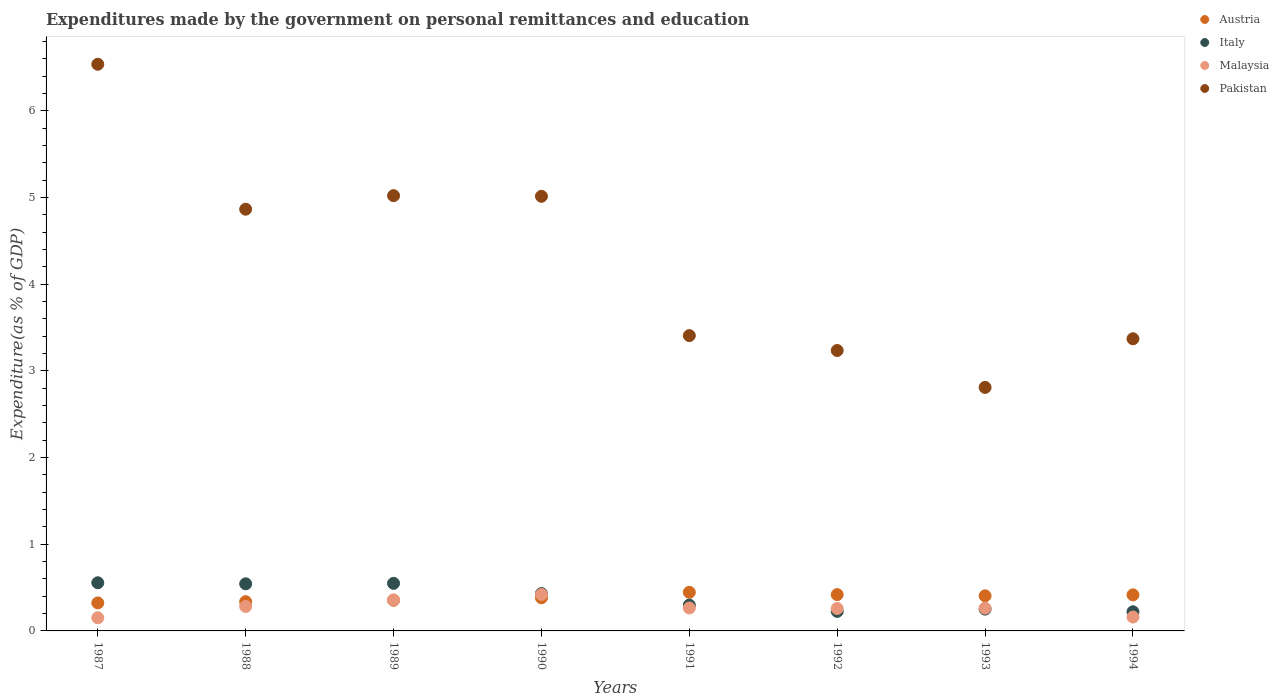How many different coloured dotlines are there?
Your answer should be very brief. 4. Is the number of dotlines equal to the number of legend labels?
Your response must be concise. Yes. What is the expenditures made by the government on personal remittances and education in Pakistan in 1994?
Your answer should be very brief. 3.37. Across all years, what is the maximum expenditures made by the government on personal remittances and education in Austria?
Give a very brief answer. 0.45. Across all years, what is the minimum expenditures made by the government on personal remittances and education in Pakistan?
Ensure brevity in your answer.  2.81. In which year was the expenditures made by the government on personal remittances and education in Pakistan maximum?
Provide a succinct answer. 1987. What is the total expenditures made by the government on personal remittances and education in Austria in the graph?
Your answer should be very brief. 3.08. What is the difference between the expenditures made by the government on personal remittances and education in Austria in 1987 and that in 1992?
Provide a short and direct response. -0.1. What is the difference between the expenditures made by the government on personal remittances and education in Italy in 1988 and the expenditures made by the government on personal remittances and education in Malaysia in 1994?
Ensure brevity in your answer.  0.38. What is the average expenditures made by the government on personal remittances and education in Pakistan per year?
Make the answer very short. 4.28. In the year 1990, what is the difference between the expenditures made by the government on personal remittances and education in Italy and expenditures made by the government on personal remittances and education in Pakistan?
Provide a succinct answer. -4.58. What is the ratio of the expenditures made by the government on personal remittances and education in Italy in 1988 to that in 1994?
Your response must be concise. 2.46. What is the difference between the highest and the second highest expenditures made by the government on personal remittances and education in Malaysia?
Ensure brevity in your answer.  0.06. What is the difference between the highest and the lowest expenditures made by the government on personal remittances and education in Pakistan?
Ensure brevity in your answer.  3.73. Is it the case that in every year, the sum of the expenditures made by the government on personal remittances and education in Italy and expenditures made by the government on personal remittances and education in Pakistan  is greater than the expenditures made by the government on personal remittances and education in Austria?
Offer a very short reply. Yes. Is the expenditures made by the government on personal remittances and education in Malaysia strictly greater than the expenditures made by the government on personal remittances and education in Italy over the years?
Keep it short and to the point. No. How many dotlines are there?
Offer a very short reply. 4. What is the difference between two consecutive major ticks on the Y-axis?
Make the answer very short. 1. Does the graph contain any zero values?
Your answer should be compact. No. How are the legend labels stacked?
Offer a terse response. Vertical. What is the title of the graph?
Your answer should be compact. Expenditures made by the government on personal remittances and education. Does "Iceland" appear as one of the legend labels in the graph?
Your answer should be compact. No. What is the label or title of the Y-axis?
Your answer should be very brief. Expenditure(as % of GDP). What is the Expenditure(as % of GDP) of Austria in 1987?
Keep it short and to the point. 0.32. What is the Expenditure(as % of GDP) in Italy in 1987?
Keep it short and to the point. 0.56. What is the Expenditure(as % of GDP) in Malaysia in 1987?
Make the answer very short. 0.15. What is the Expenditure(as % of GDP) of Pakistan in 1987?
Make the answer very short. 6.54. What is the Expenditure(as % of GDP) of Austria in 1988?
Offer a very short reply. 0.34. What is the Expenditure(as % of GDP) of Italy in 1988?
Ensure brevity in your answer.  0.54. What is the Expenditure(as % of GDP) in Malaysia in 1988?
Give a very brief answer. 0.28. What is the Expenditure(as % of GDP) in Pakistan in 1988?
Keep it short and to the point. 4.87. What is the Expenditure(as % of GDP) of Austria in 1989?
Provide a short and direct response. 0.35. What is the Expenditure(as % of GDP) of Italy in 1989?
Provide a succinct answer. 0.55. What is the Expenditure(as % of GDP) of Malaysia in 1989?
Your answer should be very brief. 0.36. What is the Expenditure(as % of GDP) of Pakistan in 1989?
Offer a very short reply. 5.02. What is the Expenditure(as % of GDP) in Austria in 1990?
Your answer should be compact. 0.38. What is the Expenditure(as % of GDP) of Italy in 1990?
Your answer should be compact. 0.43. What is the Expenditure(as % of GDP) in Malaysia in 1990?
Make the answer very short. 0.42. What is the Expenditure(as % of GDP) of Pakistan in 1990?
Your answer should be compact. 5.01. What is the Expenditure(as % of GDP) of Austria in 1991?
Your answer should be compact. 0.45. What is the Expenditure(as % of GDP) of Italy in 1991?
Your answer should be very brief. 0.3. What is the Expenditure(as % of GDP) in Malaysia in 1991?
Provide a succinct answer. 0.26. What is the Expenditure(as % of GDP) in Pakistan in 1991?
Your answer should be compact. 3.41. What is the Expenditure(as % of GDP) in Austria in 1992?
Make the answer very short. 0.42. What is the Expenditure(as % of GDP) of Italy in 1992?
Make the answer very short. 0.23. What is the Expenditure(as % of GDP) in Malaysia in 1992?
Your answer should be very brief. 0.26. What is the Expenditure(as % of GDP) of Pakistan in 1992?
Give a very brief answer. 3.24. What is the Expenditure(as % of GDP) in Austria in 1993?
Offer a terse response. 0.4. What is the Expenditure(as % of GDP) in Italy in 1993?
Give a very brief answer. 0.25. What is the Expenditure(as % of GDP) of Malaysia in 1993?
Your answer should be very brief. 0.26. What is the Expenditure(as % of GDP) in Pakistan in 1993?
Provide a short and direct response. 2.81. What is the Expenditure(as % of GDP) of Austria in 1994?
Your response must be concise. 0.42. What is the Expenditure(as % of GDP) of Italy in 1994?
Provide a short and direct response. 0.22. What is the Expenditure(as % of GDP) of Malaysia in 1994?
Provide a succinct answer. 0.16. What is the Expenditure(as % of GDP) in Pakistan in 1994?
Your answer should be compact. 3.37. Across all years, what is the maximum Expenditure(as % of GDP) of Austria?
Your answer should be very brief. 0.45. Across all years, what is the maximum Expenditure(as % of GDP) of Italy?
Ensure brevity in your answer.  0.56. Across all years, what is the maximum Expenditure(as % of GDP) in Malaysia?
Give a very brief answer. 0.42. Across all years, what is the maximum Expenditure(as % of GDP) in Pakistan?
Keep it short and to the point. 6.54. Across all years, what is the minimum Expenditure(as % of GDP) of Austria?
Make the answer very short. 0.32. Across all years, what is the minimum Expenditure(as % of GDP) of Italy?
Ensure brevity in your answer.  0.22. Across all years, what is the minimum Expenditure(as % of GDP) in Malaysia?
Ensure brevity in your answer.  0.15. Across all years, what is the minimum Expenditure(as % of GDP) in Pakistan?
Make the answer very short. 2.81. What is the total Expenditure(as % of GDP) of Austria in the graph?
Your response must be concise. 3.08. What is the total Expenditure(as % of GDP) in Italy in the graph?
Give a very brief answer. 3.07. What is the total Expenditure(as % of GDP) of Malaysia in the graph?
Your answer should be compact. 2.16. What is the total Expenditure(as % of GDP) in Pakistan in the graph?
Keep it short and to the point. 34.26. What is the difference between the Expenditure(as % of GDP) in Austria in 1987 and that in 1988?
Offer a terse response. -0.01. What is the difference between the Expenditure(as % of GDP) in Italy in 1987 and that in 1988?
Make the answer very short. 0.01. What is the difference between the Expenditure(as % of GDP) of Malaysia in 1987 and that in 1988?
Your response must be concise. -0.13. What is the difference between the Expenditure(as % of GDP) of Pakistan in 1987 and that in 1988?
Provide a succinct answer. 1.67. What is the difference between the Expenditure(as % of GDP) of Austria in 1987 and that in 1989?
Provide a short and direct response. -0.03. What is the difference between the Expenditure(as % of GDP) of Italy in 1987 and that in 1989?
Make the answer very short. 0.01. What is the difference between the Expenditure(as % of GDP) in Malaysia in 1987 and that in 1989?
Ensure brevity in your answer.  -0.21. What is the difference between the Expenditure(as % of GDP) of Pakistan in 1987 and that in 1989?
Provide a short and direct response. 1.52. What is the difference between the Expenditure(as % of GDP) in Austria in 1987 and that in 1990?
Provide a short and direct response. -0.06. What is the difference between the Expenditure(as % of GDP) of Italy in 1987 and that in 1990?
Give a very brief answer. 0.12. What is the difference between the Expenditure(as % of GDP) of Malaysia in 1987 and that in 1990?
Your answer should be compact. -0.27. What is the difference between the Expenditure(as % of GDP) in Pakistan in 1987 and that in 1990?
Your answer should be compact. 1.52. What is the difference between the Expenditure(as % of GDP) in Austria in 1987 and that in 1991?
Ensure brevity in your answer.  -0.12. What is the difference between the Expenditure(as % of GDP) of Italy in 1987 and that in 1991?
Your answer should be very brief. 0.26. What is the difference between the Expenditure(as % of GDP) of Malaysia in 1987 and that in 1991?
Keep it short and to the point. -0.11. What is the difference between the Expenditure(as % of GDP) in Pakistan in 1987 and that in 1991?
Provide a succinct answer. 3.13. What is the difference between the Expenditure(as % of GDP) of Austria in 1987 and that in 1992?
Ensure brevity in your answer.  -0.1. What is the difference between the Expenditure(as % of GDP) in Italy in 1987 and that in 1992?
Keep it short and to the point. 0.33. What is the difference between the Expenditure(as % of GDP) of Malaysia in 1987 and that in 1992?
Offer a very short reply. -0.11. What is the difference between the Expenditure(as % of GDP) in Pakistan in 1987 and that in 1992?
Your response must be concise. 3.3. What is the difference between the Expenditure(as % of GDP) of Austria in 1987 and that in 1993?
Make the answer very short. -0.08. What is the difference between the Expenditure(as % of GDP) in Italy in 1987 and that in 1993?
Offer a very short reply. 0.3. What is the difference between the Expenditure(as % of GDP) in Malaysia in 1987 and that in 1993?
Give a very brief answer. -0.11. What is the difference between the Expenditure(as % of GDP) of Pakistan in 1987 and that in 1993?
Your response must be concise. 3.73. What is the difference between the Expenditure(as % of GDP) in Austria in 1987 and that in 1994?
Offer a terse response. -0.09. What is the difference between the Expenditure(as % of GDP) in Italy in 1987 and that in 1994?
Your response must be concise. 0.33. What is the difference between the Expenditure(as % of GDP) in Malaysia in 1987 and that in 1994?
Ensure brevity in your answer.  -0.01. What is the difference between the Expenditure(as % of GDP) in Pakistan in 1987 and that in 1994?
Give a very brief answer. 3.17. What is the difference between the Expenditure(as % of GDP) of Austria in 1988 and that in 1989?
Provide a short and direct response. -0.02. What is the difference between the Expenditure(as % of GDP) in Italy in 1988 and that in 1989?
Your response must be concise. -0.01. What is the difference between the Expenditure(as % of GDP) in Malaysia in 1988 and that in 1989?
Ensure brevity in your answer.  -0.07. What is the difference between the Expenditure(as % of GDP) in Pakistan in 1988 and that in 1989?
Your answer should be compact. -0.16. What is the difference between the Expenditure(as % of GDP) in Austria in 1988 and that in 1990?
Make the answer very short. -0.04. What is the difference between the Expenditure(as % of GDP) in Italy in 1988 and that in 1990?
Your answer should be compact. 0.11. What is the difference between the Expenditure(as % of GDP) of Malaysia in 1988 and that in 1990?
Your answer should be very brief. -0.14. What is the difference between the Expenditure(as % of GDP) of Pakistan in 1988 and that in 1990?
Give a very brief answer. -0.15. What is the difference between the Expenditure(as % of GDP) in Austria in 1988 and that in 1991?
Ensure brevity in your answer.  -0.11. What is the difference between the Expenditure(as % of GDP) in Italy in 1988 and that in 1991?
Make the answer very short. 0.25. What is the difference between the Expenditure(as % of GDP) in Malaysia in 1988 and that in 1991?
Offer a very short reply. 0.02. What is the difference between the Expenditure(as % of GDP) in Pakistan in 1988 and that in 1991?
Offer a very short reply. 1.46. What is the difference between the Expenditure(as % of GDP) of Austria in 1988 and that in 1992?
Offer a terse response. -0.08. What is the difference between the Expenditure(as % of GDP) in Italy in 1988 and that in 1992?
Ensure brevity in your answer.  0.32. What is the difference between the Expenditure(as % of GDP) in Malaysia in 1988 and that in 1992?
Give a very brief answer. 0.02. What is the difference between the Expenditure(as % of GDP) of Pakistan in 1988 and that in 1992?
Make the answer very short. 1.63. What is the difference between the Expenditure(as % of GDP) in Austria in 1988 and that in 1993?
Provide a succinct answer. -0.07. What is the difference between the Expenditure(as % of GDP) of Italy in 1988 and that in 1993?
Provide a short and direct response. 0.29. What is the difference between the Expenditure(as % of GDP) in Malaysia in 1988 and that in 1993?
Keep it short and to the point. 0.02. What is the difference between the Expenditure(as % of GDP) of Pakistan in 1988 and that in 1993?
Your answer should be compact. 2.06. What is the difference between the Expenditure(as % of GDP) of Austria in 1988 and that in 1994?
Ensure brevity in your answer.  -0.08. What is the difference between the Expenditure(as % of GDP) of Italy in 1988 and that in 1994?
Provide a succinct answer. 0.32. What is the difference between the Expenditure(as % of GDP) of Malaysia in 1988 and that in 1994?
Provide a short and direct response. 0.12. What is the difference between the Expenditure(as % of GDP) in Pakistan in 1988 and that in 1994?
Make the answer very short. 1.49. What is the difference between the Expenditure(as % of GDP) in Austria in 1989 and that in 1990?
Make the answer very short. -0.03. What is the difference between the Expenditure(as % of GDP) in Italy in 1989 and that in 1990?
Keep it short and to the point. 0.12. What is the difference between the Expenditure(as % of GDP) in Malaysia in 1989 and that in 1990?
Provide a short and direct response. -0.06. What is the difference between the Expenditure(as % of GDP) in Pakistan in 1989 and that in 1990?
Provide a succinct answer. 0.01. What is the difference between the Expenditure(as % of GDP) of Austria in 1989 and that in 1991?
Offer a terse response. -0.09. What is the difference between the Expenditure(as % of GDP) of Italy in 1989 and that in 1991?
Provide a short and direct response. 0.25. What is the difference between the Expenditure(as % of GDP) of Malaysia in 1989 and that in 1991?
Keep it short and to the point. 0.09. What is the difference between the Expenditure(as % of GDP) in Pakistan in 1989 and that in 1991?
Ensure brevity in your answer.  1.61. What is the difference between the Expenditure(as % of GDP) in Austria in 1989 and that in 1992?
Your response must be concise. -0.07. What is the difference between the Expenditure(as % of GDP) of Italy in 1989 and that in 1992?
Ensure brevity in your answer.  0.32. What is the difference between the Expenditure(as % of GDP) in Malaysia in 1989 and that in 1992?
Keep it short and to the point. 0.1. What is the difference between the Expenditure(as % of GDP) in Pakistan in 1989 and that in 1992?
Your answer should be compact. 1.79. What is the difference between the Expenditure(as % of GDP) in Austria in 1989 and that in 1993?
Your answer should be compact. -0.05. What is the difference between the Expenditure(as % of GDP) in Italy in 1989 and that in 1993?
Ensure brevity in your answer.  0.3. What is the difference between the Expenditure(as % of GDP) of Malaysia in 1989 and that in 1993?
Ensure brevity in your answer.  0.09. What is the difference between the Expenditure(as % of GDP) in Pakistan in 1989 and that in 1993?
Your answer should be very brief. 2.21. What is the difference between the Expenditure(as % of GDP) in Austria in 1989 and that in 1994?
Provide a succinct answer. -0.06. What is the difference between the Expenditure(as % of GDP) of Italy in 1989 and that in 1994?
Your answer should be very brief. 0.33. What is the difference between the Expenditure(as % of GDP) of Malaysia in 1989 and that in 1994?
Your answer should be compact. 0.2. What is the difference between the Expenditure(as % of GDP) of Pakistan in 1989 and that in 1994?
Provide a succinct answer. 1.65. What is the difference between the Expenditure(as % of GDP) in Austria in 1990 and that in 1991?
Provide a short and direct response. -0.06. What is the difference between the Expenditure(as % of GDP) in Italy in 1990 and that in 1991?
Offer a very short reply. 0.13. What is the difference between the Expenditure(as % of GDP) of Malaysia in 1990 and that in 1991?
Offer a very short reply. 0.16. What is the difference between the Expenditure(as % of GDP) in Pakistan in 1990 and that in 1991?
Provide a short and direct response. 1.61. What is the difference between the Expenditure(as % of GDP) in Austria in 1990 and that in 1992?
Make the answer very short. -0.04. What is the difference between the Expenditure(as % of GDP) of Italy in 1990 and that in 1992?
Your answer should be compact. 0.21. What is the difference between the Expenditure(as % of GDP) of Malaysia in 1990 and that in 1992?
Provide a short and direct response. 0.16. What is the difference between the Expenditure(as % of GDP) in Pakistan in 1990 and that in 1992?
Your answer should be compact. 1.78. What is the difference between the Expenditure(as % of GDP) in Austria in 1990 and that in 1993?
Provide a short and direct response. -0.02. What is the difference between the Expenditure(as % of GDP) of Italy in 1990 and that in 1993?
Your answer should be compact. 0.18. What is the difference between the Expenditure(as % of GDP) of Malaysia in 1990 and that in 1993?
Ensure brevity in your answer.  0.16. What is the difference between the Expenditure(as % of GDP) in Pakistan in 1990 and that in 1993?
Make the answer very short. 2.2. What is the difference between the Expenditure(as % of GDP) in Austria in 1990 and that in 1994?
Give a very brief answer. -0.03. What is the difference between the Expenditure(as % of GDP) in Italy in 1990 and that in 1994?
Ensure brevity in your answer.  0.21. What is the difference between the Expenditure(as % of GDP) of Malaysia in 1990 and that in 1994?
Your response must be concise. 0.26. What is the difference between the Expenditure(as % of GDP) in Pakistan in 1990 and that in 1994?
Provide a succinct answer. 1.64. What is the difference between the Expenditure(as % of GDP) of Austria in 1991 and that in 1992?
Offer a terse response. 0.03. What is the difference between the Expenditure(as % of GDP) of Italy in 1991 and that in 1992?
Offer a terse response. 0.07. What is the difference between the Expenditure(as % of GDP) in Malaysia in 1991 and that in 1992?
Make the answer very short. 0.01. What is the difference between the Expenditure(as % of GDP) of Pakistan in 1991 and that in 1992?
Your answer should be compact. 0.17. What is the difference between the Expenditure(as % of GDP) of Austria in 1991 and that in 1993?
Your response must be concise. 0.04. What is the difference between the Expenditure(as % of GDP) in Italy in 1991 and that in 1993?
Offer a terse response. 0.05. What is the difference between the Expenditure(as % of GDP) in Malaysia in 1991 and that in 1993?
Your answer should be compact. 0. What is the difference between the Expenditure(as % of GDP) of Pakistan in 1991 and that in 1993?
Your answer should be very brief. 0.6. What is the difference between the Expenditure(as % of GDP) in Austria in 1991 and that in 1994?
Make the answer very short. 0.03. What is the difference between the Expenditure(as % of GDP) in Italy in 1991 and that in 1994?
Provide a succinct answer. 0.08. What is the difference between the Expenditure(as % of GDP) in Malaysia in 1991 and that in 1994?
Your answer should be very brief. 0.1. What is the difference between the Expenditure(as % of GDP) in Pakistan in 1991 and that in 1994?
Your response must be concise. 0.04. What is the difference between the Expenditure(as % of GDP) of Austria in 1992 and that in 1993?
Ensure brevity in your answer.  0.01. What is the difference between the Expenditure(as % of GDP) of Italy in 1992 and that in 1993?
Provide a succinct answer. -0.03. What is the difference between the Expenditure(as % of GDP) in Malaysia in 1992 and that in 1993?
Offer a very short reply. -0. What is the difference between the Expenditure(as % of GDP) in Pakistan in 1992 and that in 1993?
Your response must be concise. 0.43. What is the difference between the Expenditure(as % of GDP) in Austria in 1992 and that in 1994?
Provide a short and direct response. 0. What is the difference between the Expenditure(as % of GDP) in Italy in 1992 and that in 1994?
Ensure brevity in your answer.  0. What is the difference between the Expenditure(as % of GDP) of Malaysia in 1992 and that in 1994?
Make the answer very short. 0.1. What is the difference between the Expenditure(as % of GDP) of Pakistan in 1992 and that in 1994?
Keep it short and to the point. -0.14. What is the difference between the Expenditure(as % of GDP) of Austria in 1993 and that in 1994?
Offer a very short reply. -0.01. What is the difference between the Expenditure(as % of GDP) of Italy in 1993 and that in 1994?
Your response must be concise. 0.03. What is the difference between the Expenditure(as % of GDP) of Malaysia in 1993 and that in 1994?
Make the answer very short. 0.1. What is the difference between the Expenditure(as % of GDP) of Pakistan in 1993 and that in 1994?
Keep it short and to the point. -0.56. What is the difference between the Expenditure(as % of GDP) of Austria in 1987 and the Expenditure(as % of GDP) of Italy in 1988?
Offer a very short reply. -0.22. What is the difference between the Expenditure(as % of GDP) in Austria in 1987 and the Expenditure(as % of GDP) in Malaysia in 1988?
Offer a very short reply. 0.04. What is the difference between the Expenditure(as % of GDP) in Austria in 1987 and the Expenditure(as % of GDP) in Pakistan in 1988?
Provide a succinct answer. -4.54. What is the difference between the Expenditure(as % of GDP) of Italy in 1987 and the Expenditure(as % of GDP) of Malaysia in 1988?
Your answer should be compact. 0.27. What is the difference between the Expenditure(as % of GDP) of Italy in 1987 and the Expenditure(as % of GDP) of Pakistan in 1988?
Give a very brief answer. -4.31. What is the difference between the Expenditure(as % of GDP) of Malaysia in 1987 and the Expenditure(as % of GDP) of Pakistan in 1988?
Offer a very short reply. -4.71. What is the difference between the Expenditure(as % of GDP) of Austria in 1987 and the Expenditure(as % of GDP) of Italy in 1989?
Provide a succinct answer. -0.23. What is the difference between the Expenditure(as % of GDP) in Austria in 1987 and the Expenditure(as % of GDP) in Malaysia in 1989?
Your response must be concise. -0.03. What is the difference between the Expenditure(as % of GDP) in Austria in 1987 and the Expenditure(as % of GDP) in Pakistan in 1989?
Make the answer very short. -4.7. What is the difference between the Expenditure(as % of GDP) of Italy in 1987 and the Expenditure(as % of GDP) of Malaysia in 1989?
Your answer should be compact. 0.2. What is the difference between the Expenditure(as % of GDP) in Italy in 1987 and the Expenditure(as % of GDP) in Pakistan in 1989?
Ensure brevity in your answer.  -4.47. What is the difference between the Expenditure(as % of GDP) in Malaysia in 1987 and the Expenditure(as % of GDP) in Pakistan in 1989?
Keep it short and to the point. -4.87. What is the difference between the Expenditure(as % of GDP) of Austria in 1987 and the Expenditure(as % of GDP) of Italy in 1990?
Give a very brief answer. -0.11. What is the difference between the Expenditure(as % of GDP) of Austria in 1987 and the Expenditure(as % of GDP) of Malaysia in 1990?
Keep it short and to the point. -0.1. What is the difference between the Expenditure(as % of GDP) of Austria in 1987 and the Expenditure(as % of GDP) of Pakistan in 1990?
Ensure brevity in your answer.  -4.69. What is the difference between the Expenditure(as % of GDP) of Italy in 1987 and the Expenditure(as % of GDP) of Malaysia in 1990?
Provide a succinct answer. 0.13. What is the difference between the Expenditure(as % of GDP) of Italy in 1987 and the Expenditure(as % of GDP) of Pakistan in 1990?
Ensure brevity in your answer.  -4.46. What is the difference between the Expenditure(as % of GDP) in Malaysia in 1987 and the Expenditure(as % of GDP) in Pakistan in 1990?
Provide a short and direct response. -4.86. What is the difference between the Expenditure(as % of GDP) in Austria in 1987 and the Expenditure(as % of GDP) in Italy in 1991?
Give a very brief answer. 0.03. What is the difference between the Expenditure(as % of GDP) in Austria in 1987 and the Expenditure(as % of GDP) in Malaysia in 1991?
Your answer should be very brief. 0.06. What is the difference between the Expenditure(as % of GDP) of Austria in 1987 and the Expenditure(as % of GDP) of Pakistan in 1991?
Provide a short and direct response. -3.08. What is the difference between the Expenditure(as % of GDP) in Italy in 1987 and the Expenditure(as % of GDP) in Malaysia in 1991?
Provide a succinct answer. 0.29. What is the difference between the Expenditure(as % of GDP) of Italy in 1987 and the Expenditure(as % of GDP) of Pakistan in 1991?
Your answer should be very brief. -2.85. What is the difference between the Expenditure(as % of GDP) of Malaysia in 1987 and the Expenditure(as % of GDP) of Pakistan in 1991?
Offer a terse response. -3.26. What is the difference between the Expenditure(as % of GDP) of Austria in 1987 and the Expenditure(as % of GDP) of Italy in 1992?
Make the answer very short. 0.1. What is the difference between the Expenditure(as % of GDP) of Austria in 1987 and the Expenditure(as % of GDP) of Malaysia in 1992?
Your answer should be very brief. 0.06. What is the difference between the Expenditure(as % of GDP) of Austria in 1987 and the Expenditure(as % of GDP) of Pakistan in 1992?
Provide a short and direct response. -2.91. What is the difference between the Expenditure(as % of GDP) of Italy in 1987 and the Expenditure(as % of GDP) of Malaysia in 1992?
Your response must be concise. 0.3. What is the difference between the Expenditure(as % of GDP) in Italy in 1987 and the Expenditure(as % of GDP) in Pakistan in 1992?
Your response must be concise. -2.68. What is the difference between the Expenditure(as % of GDP) in Malaysia in 1987 and the Expenditure(as % of GDP) in Pakistan in 1992?
Your response must be concise. -3.08. What is the difference between the Expenditure(as % of GDP) of Austria in 1987 and the Expenditure(as % of GDP) of Italy in 1993?
Offer a terse response. 0.07. What is the difference between the Expenditure(as % of GDP) of Austria in 1987 and the Expenditure(as % of GDP) of Malaysia in 1993?
Offer a terse response. 0.06. What is the difference between the Expenditure(as % of GDP) of Austria in 1987 and the Expenditure(as % of GDP) of Pakistan in 1993?
Your response must be concise. -2.49. What is the difference between the Expenditure(as % of GDP) in Italy in 1987 and the Expenditure(as % of GDP) in Malaysia in 1993?
Keep it short and to the point. 0.29. What is the difference between the Expenditure(as % of GDP) in Italy in 1987 and the Expenditure(as % of GDP) in Pakistan in 1993?
Your response must be concise. -2.25. What is the difference between the Expenditure(as % of GDP) in Malaysia in 1987 and the Expenditure(as % of GDP) in Pakistan in 1993?
Make the answer very short. -2.66. What is the difference between the Expenditure(as % of GDP) in Austria in 1987 and the Expenditure(as % of GDP) in Italy in 1994?
Keep it short and to the point. 0.1. What is the difference between the Expenditure(as % of GDP) in Austria in 1987 and the Expenditure(as % of GDP) in Malaysia in 1994?
Your answer should be very brief. 0.16. What is the difference between the Expenditure(as % of GDP) in Austria in 1987 and the Expenditure(as % of GDP) in Pakistan in 1994?
Give a very brief answer. -3.05. What is the difference between the Expenditure(as % of GDP) of Italy in 1987 and the Expenditure(as % of GDP) of Malaysia in 1994?
Keep it short and to the point. 0.4. What is the difference between the Expenditure(as % of GDP) of Italy in 1987 and the Expenditure(as % of GDP) of Pakistan in 1994?
Your answer should be compact. -2.82. What is the difference between the Expenditure(as % of GDP) in Malaysia in 1987 and the Expenditure(as % of GDP) in Pakistan in 1994?
Offer a terse response. -3.22. What is the difference between the Expenditure(as % of GDP) in Austria in 1988 and the Expenditure(as % of GDP) in Italy in 1989?
Provide a short and direct response. -0.21. What is the difference between the Expenditure(as % of GDP) in Austria in 1988 and the Expenditure(as % of GDP) in Malaysia in 1989?
Offer a terse response. -0.02. What is the difference between the Expenditure(as % of GDP) of Austria in 1988 and the Expenditure(as % of GDP) of Pakistan in 1989?
Your answer should be very brief. -4.68. What is the difference between the Expenditure(as % of GDP) in Italy in 1988 and the Expenditure(as % of GDP) in Malaysia in 1989?
Your answer should be compact. 0.19. What is the difference between the Expenditure(as % of GDP) of Italy in 1988 and the Expenditure(as % of GDP) of Pakistan in 1989?
Give a very brief answer. -4.48. What is the difference between the Expenditure(as % of GDP) of Malaysia in 1988 and the Expenditure(as % of GDP) of Pakistan in 1989?
Offer a terse response. -4.74. What is the difference between the Expenditure(as % of GDP) in Austria in 1988 and the Expenditure(as % of GDP) in Italy in 1990?
Provide a succinct answer. -0.09. What is the difference between the Expenditure(as % of GDP) of Austria in 1988 and the Expenditure(as % of GDP) of Malaysia in 1990?
Offer a terse response. -0.08. What is the difference between the Expenditure(as % of GDP) in Austria in 1988 and the Expenditure(as % of GDP) in Pakistan in 1990?
Offer a terse response. -4.68. What is the difference between the Expenditure(as % of GDP) in Italy in 1988 and the Expenditure(as % of GDP) in Malaysia in 1990?
Give a very brief answer. 0.12. What is the difference between the Expenditure(as % of GDP) in Italy in 1988 and the Expenditure(as % of GDP) in Pakistan in 1990?
Make the answer very short. -4.47. What is the difference between the Expenditure(as % of GDP) of Malaysia in 1988 and the Expenditure(as % of GDP) of Pakistan in 1990?
Your response must be concise. -4.73. What is the difference between the Expenditure(as % of GDP) of Austria in 1988 and the Expenditure(as % of GDP) of Italy in 1991?
Your answer should be compact. 0.04. What is the difference between the Expenditure(as % of GDP) in Austria in 1988 and the Expenditure(as % of GDP) in Malaysia in 1991?
Your answer should be compact. 0.07. What is the difference between the Expenditure(as % of GDP) of Austria in 1988 and the Expenditure(as % of GDP) of Pakistan in 1991?
Keep it short and to the point. -3.07. What is the difference between the Expenditure(as % of GDP) in Italy in 1988 and the Expenditure(as % of GDP) in Malaysia in 1991?
Provide a short and direct response. 0.28. What is the difference between the Expenditure(as % of GDP) in Italy in 1988 and the Expenditure(as % of GDP) in Pakistan in 1991?
Keep it short and to the point. -2.86. What is the difference between the Expenditure(as % of GDP) in Malaysia in 1988 and the Expenditure(as % of GDP) in Pakistan in 1991?
Ensure brevity in your answer.  -3.12. What is the difference between the Expenditure(as % of GDP) of Austria in 1988 and the Expenditure(as % of GDP) of Italy in 1992?
Offer a very short reply. 0.11. What is the difference between the Expenditure(as % of GDP) in Austria in 1988 and the Expenditure(as % of GDP) in Malaysia in 1992?
Make the answer very short. 0.08. What is the difference between the Expenditure(as % of GDP) of Austria in 1988 and the Expenditure(as % of GDP) of Pakistan in 1992?
Offer a very short reply. -2.9. What is the difference between the Expenditure(as % of GDP) in Italy in 1988 and the Expenditure(as % of GDP) in Malaysia in 1992?
Your answer should be very brief. 0.28. What is the difference between the Expenditure(as % of GDP) in Italy in 1988 and the Expenditure(as % of GDP) in Pakistan in 1992?
Give a very brief answer. -2.69. What is the difference between the Expenditure(as % of GDP) of Malaysia in 1988 and the Expenditure(as % of GDP) of Pakistan in 1992?
Ensure brevity in your answer.  -2.95. What is the difference between the Expenditure(as % of GDP) of Austria in 1988 and the Expenditure(as % of GDP) of Italy in 1993?
Offer a very short reply. 0.09. What is the difference between the Expenditure(as % of GDP) of Austria in 1988 and the Expenditure(as % of GDP) of Malaysia in 1993?
Provide a short and direct response. 0.07. What is the difference between the Expenditure(as % of GDP) in Austria in 1988 and the Expenditure(as % of GDP) in Pakistan in 1993?
Offer a terse response. -2.47. What is the difference between the Expenditure(as % of GDP) in Italy in 1988 and the Expenditure(as % of GDP) in Malaysia in 1993?
Ensure brevity in your answer.  0.28. What is the difference between the Expenditure(as % of GDP) in Italy in 1988 and the Expenditure(as % of GDP) in Pakistan in 1993?
Provide a short and direct response. -2.27. What is the difference between the Expenditure(as % of GDP) in Malaysia in 1988 and the Expenditure(as % of GDP) in Pakistan in 1993?
Provide a succinct answer. -2.53. What is the difference between the Expenditure(as % of GDP) in Austria in 1988 and the Expenditure(as % of GDP) in Italy in 1994?
Offer a very short reply. 0.12. What is the difference between the Expenditure(as % of GDP) in Austria in 1988 and the Expenditure(as % of GDP) in Malaysia in 1994?
Make the answer very short. 0.18. What is the difference between the Expenditure(as % of GDP) of Austria in 1988 and the Expenditure(as % of GDP) of Pakistan in 1994?
Your answer should be very brief. -3.03. What is the difference between the Expenditure(as % of GDP) in Italy in 1988 and the Expenditure(as % of GDP) in Malaysia in 1994?
Provide a short and direct response. 0.38. What is the difference between the Expenditure(as % of GDP) of Italy in 1988 and the Expenditure(as % of GDP) of Pakistan in 1994?
Make the answer very short. -2.83. What is the difference between the Expenditure(as % of GDP) of Malaysia in 1988 and the Expenditure(as % of GDP) of Pakistan in 1994?
Your response must be concise. -3.09. What is the difference between the Expenditure(as % of GDP) of Austria in 1989 and the Expenditure(as % of GDP) of Italy in 1990?
Your response must be concise. -0.08. What is the difference between the Expenditure(as % of GDP) of Austria in 1989 and the Expenditure(as % of GDP) of Malaysia in 1990?
Keep it short and to the point. -0.07. What is the difference between the Expenditure(as % of GDP) of Austria in 1989 and the Expenditure(as % of GDP) of Pakistan in 1990?
Offer a terse response. -4.66. What is the difference between the Expenditure(as % of GDP) in Italy in 1989 and the Expenditure(as % of GDP) in Malaysia in 1990?
Offer a terse response. 0.13. What is the difference between the Expenditure(as % of GDP) in Italy in 1989 and the Expenditure(as % of GDP) in Pakistan in 1990?
Give a very brief answer. -4.47. What is the difference between the Expenditure(as % of GDP) of Malaysia in 1989 and the Expenditure(as % of GDP) of Pakistan in 1990?
Provide a succinct answer. -4.66. What is the difference between the Expenditure(as % of GDP) in Austria in 1989 and the Expenditure(as % of GDP) in Italy in 1991?
Give a very brief answer. 0.06. What is the difference between the Expenditure(as % of GDP) of Austria in 1989 and the Expenditure(as % of GDP) of Malaysia in 1991?
Make the answer very short. 0.09. What is the difference between the Expenditure(as % of GDP) of Austria in 1989 and the Expenditure(as % of GDP) of Pakistan in 1991?
Your answer should be compact. -3.05. What is the difference between the Expenditure(as % of GDP) in Italy in 1989 and the Expenditure(as % of GDP) in Malaysia in 1991?
Make the answer very short. 0.28. What is the difference between the Expenditure(as % of GDP) of Italy in 1989 and the Expenditure(as % of GDP) of Pakistan in 1991?
Keep it short and to the point. -2.86. What is the difference between the Expenditure(as % of GDP) in Malaysia in 1989 and the Expenditure(as % of GDP) in Pakistan in 1991?
Your response must be concise. -3.05. What is the difference between the Expenditure(as % of GDP) of Austria in 1989 and the Expenditure(as % of GDP) of Italy in 1992?
Give a very brief answer. 0.13. What is the difference between the Expenditure(as % of GDP) in Austria in 1989 and the Expenditure(as % of GDP) in Malaysia in 1992?
Your response must be concise. 0.09. What is the difference between the Expenditure(as % of GDP) in Austria in 1989 and the Expenditure(as % of GDP) in Pakistan in 1992?
Your answer should be very brief. -2.88. What is the difference between the Expenditure(as % of GDP) in Italy in 1989 and the Expenditure(as % of GDP) in Malaysia in 1992?
Provide a short and direct response. 0.29. What is the difference between the Expenditure(as % of GDP) in Italy in 1989 and the Expenditure(as % of GDP) in Pakistan in 1992?
Provide a succinct answer. -2.69. What is the difference between the Expenditure(as % of GDP) in Malaysia in 1989 and the Expenditure(as % of GDP) in Pakistan in 1992?
Offer a very short reply. -2.88. What is the difference between the Expenditure(as % of GDP) in Austria in 1989 and the Expenditure(as % of GDP) in Italy in 1993?
Your response must be concise. 0.1. What is the difference between the Expenditure(as % of GDP) of Austria in 1989 and the Expenditure(as % of GDP) of Malaysia in 1993?
Provide a short and direct response. 0.09. What is the difference between the Expenditure(as % of GDP) in Austria in 1989 and the Expenditure(as % of GDP) in Pakistan in 1993?
Provide a succinct answer. -2.46. What is the difference between the Expenditure(as % of GDP) in Italy in 1989 and the Expenditure(as % of GDP) in Malaysia in 1993?
Ensure brevity in your answer.  0.29. What is the difference between the Expenditure(as % of GDP) in Italy in 1989 and the Expenditure(as % of GDP) in Pakistan in 1993?
Your response must be concise. -2.26. What is the difference between the Expenditure(as % of GDP) in Malaysia in 1989 and the Expenditure(as % of GDP) in Pakistan in 1993?
Your answer should be very brief. -2.45. What is the difference between the Expenditure(as % of GDP) in Austria in 1989 and the Expenditure(as % of GDP) in Italy in 1994?
Give a very brief answer. 0.13. What is the difference between the Expenditure(as % of GDP) of Austria in 1989 and the Expenditure(as % of GDP) of Malaysia in 1994?
Offer a terse response. 0.19. What is the difference between the Expenditure(as % of GDP) in Austria in 1989 and the Expenditure(as % of GDP) in Pakistan in 1994?
Offer a very short reply. -3.02. What is the difference between the Expenditure(as % of GDP) in Italy in 1989 and the Expenditure(as % of GDP) in Malaysia in 1994?
Provide a succinct answer. 0.39. What is the difference between the Expenditure(as % of GDP) in Italy in 1989 and the Expenditure(as % of GDP) in Pakistan in 1994?
Give a very brief answer. -2.82. What is the difference between the Expenditure(as % of GDP) in Malaysia in 1989 and the Expenditure(as % of GDP) in Pakistan in 1994?
Ensure brevity in your answer.  -3.01. What is the difference between the Expenditure(as % of GDP) in Austria in 1990 and the Expenditure(as % of GDP) in Italy in 1991?
Offer a terse response. 0.08. What is the difference between the Expenditure(as % of GDP) in Austria in 1990 and the Expenditure(as % of GDP) in Malaysia in 1991?
Your answer should be compact. 0.12. What is the difference between the Expenditure(as % of GDP) in Austria in 1990 and the Expenditure(as % of GDP) in Pakistan in 1991?
Your answer should be very brief. -3.02. What is the difference between the Expenditure(as % of GDP) in Italy in 1990 and the Expenditure(as % of GDP) in Malaysia in 1991?
Your answer should be very brief. 0.17. What is the difference between the Expenditure(as % of GDP) in Italy in 1990 and the Expenditure(as % of GDP) in Pakistan in 1991?
Keep it short and to the point. -2.98. What is the difference between the Expenditure(as % of GDP) in Malaysia in 1990 and the Expenditure(as % of GDP) in Pakistan in 1991?
Provide a short and direct response. -2.99. What is the difference between the Expenditure(as % of GDP) of Austria in 1990 and the Expenditure(as % of GDP) of Italy in 1992?
Give a very brief answer. 0.16. What is the difference between the Expenditure(as % of GDP) in Austria in 1990 and the Expenditure(as % of GDP) in Malaysia in 1992?
Provide a short and direct response. 0.12. What is the difference between the Expenditure(as % of GDP) of Austria in 1990 and the Expenditure(as % of GDP) of Pakistan in 1992?
Provide a short and direct response. -2.85. What is the difference between the Expenditure(as % of GDP) of Italy in 1990 and the Expenditure(as % of GDP) of Malaysia in 1992?
Offer a terse response. 0.17. What is the difference between the Expenditure(as % of GDP) of Italy in 1990 and the Expenditure(as % of GDP) of Pakistan in 1992?
Offer a terse response. -2.8. What is the difference between the Expenditure(as % of GDP) in Malaysia in 1990 and the Expenditure(as % of GDP) in Pakistan in 1992?
Keep it short and to the point. -2.81. What is the difference between the Expenditure(as % of GDP) in Austria in 1990 and the Expenditure(as % of GDP) in Italy in 1993?
Ensure brevity in your answer.  0.13. What is the difference between the Expenditure(as % of GDP) of Austria in 1990 and the Expenditure(as % of GDP) of Malaysia in 1993?
Keep it short and to the point. 0.12. What is the difference between the Expenditure(as % of GDP) of Austria in 1990 and the Expenditure(as % of GDP) of Pakistan in 1993?
Ensure brevity in your answer.  -2.43. What is the difference between the Expenditure(as % of GDP) of Italy in 1990 and the Expenditure(as % of GDP) of Malaysia in 1993?
Offer a very short reply. 0.17. What is the difference between the Expenditure(as % of GDP) of Italy in 1990 and the Expenditure(as % of GDP) of Pakistan in 1993?
Your answer should be very brief. -2.38. What is the difference between the Expenditure(as % of GDP) of Malaysia in 1990 and the Expenditure(as % of GDP) of Pakistan in 1993?
Offer a very short reply. -2.39. What is the difference between the Expenditure(as % of GDP) in Austria in 1990 and the Expenditure(as % of GDP) in Italy in 1994?
Provide a succinct answer. 0.16. What is the difference between the Expenditure(as % of GDP) in Austria in 1990 and the Expenditure(as % of GDP) in Malaysia in 1994?
Make the answer very short. 0.22. What is the difference between the Expenditure(as % of GDP) of Austria in 1990 and the Expenditure(as % of GDP) of Pakistan in 1994?
Provide a succinct answer. -2.99. What is the difference between the Expenditure(as % of GDP) in Italy in 1990 and the Expenditure(as % of GDP) in Malaysia in 1994?
Offer a very short reply. 0.27. What is the difference between the Expenditure(as % of GDP) in Italy in 1990 and the Expenditure(as % of GDP) in Pakistan in 1994?
Provide a succinct answer. -2.94. What is the difference between the Expenditure(as % of GDP) in Malaysia in 1990 and the Expenditure(as % of GDP) in Pakistan in 1994?
Your answer should be compact. -2.95. What is the difference between the Expenditure(as % of GDP) of Austria in 1991 and the Expenditure(as % of GDP) of Italy in 1992?
Offer a terse response. 0.22. What is the difference between the Expenditure(as % of GDP) in Austria in 1991 and the Expenditure(as % of GDP) in Malaysia in 1992?
Your answer should be compact. 0.19. What is the difference between the Expenditure(as % of GDP) of Austria in 1991 and the Expenditure(as % of GDP) of Pakistan in 1992?
Give a very brief answer. -2.79. What is the difference between the Expenditure(as % of GDP) of Italy in 1991 and the Expenditure(as % of GDP) of Malaysia in 1992?
Make the answer very short. 0.04. What is the difference between the Expenditure(as % of GDP) in Italy in 1991 and the Expenditure(as % of GDP) in Pakistan in 1992?
Your response must be concise. -2.94. What is the difference between the Expenditure(as % of GDP) in Malaysia in 1991 and the Expenditure(as % of GDP) in Pakistan in 1992?
Provide a short and direct response. -2.97. What is the difference between the Expenditure(as % of GDP) in Austria in 1991 and the Expenditure(as % of GDP) in Italy in 1993?
Your answer should be compact. 0.19. What is the difference between the Expenditure(as % of GDP) in Austria in 1991 and the Expenditure(as % of GDP) in Malaysia in 1993?
Ensure brevity in your answer.  0.18. What is the difference between the Expenditure(as % of GDP) of Austria in 1991 and the Expenditure(as % of GDP) of Pakistan in 1993?
Ensure brevity in your answer.  -2.36. What is the difference between the Expenditure(as % of GDP) in Italy in 1991 and the Expenditure(as % of GDP) in Malaysia in 1993?
Your response must be concise. 0.04. What is the difference between the Expenditure(as % of GDP) in Italy in 1991 and the Expenditure(as % of GDP) in Pakistan in 1993?
Ensure brevity in your answer.  -2.51. What is the difference between the Expenditure(as % of GDP) of Malaysia in 1991 and the Expenditure(as % of GDP) of Pakistan in 1993?
Your answer should be very brief. -2.54. What is the difference between the Expenditure(as % of GDP) of Austria in 1991 and the Expenditure(as % of GDP) of Italy in 1994?
Your response must be concise. 0.22. What is the difference between the Expenditure(as % of GDP) of Austria in 1991 and the Expenditure(as % of GDP) of Malaysia in 1994?
Make the answer very short. 0.29. What is the difference between the Expenditure(as % of GDP) in Austria in 1991 and the Expenditure(as % of GDP) in Pakistan in 1994?
Give a very brief answer. -2.93. What is the difference between the Expenditure(as % of GDP) of Italy in 1991 and the Expenditure(as % of GDP) of Malaysia in 1994?
Your answer should be very brief. 0.14. What is the difference between the Expenditure(as % of GDP) in Italy in 1991 and the Expenditure(as % of GDP) in Pakistan in 1994?
Ensure brevity in your answer.  -3.07. What is the difference between the Expenditure(as % of GDP) in Malaysia in 1991 and the Expenditure(as % of GDP) in Pakistan in 1994?
Make the answer very short. -3.11. What is the difference between the Expenditure(as % of GDP) of Austria in 1992 and the Expenditure(as % of GDP) of Italy in 1993?
Ensure brevity in your answer.  0.17. What is the difference between the Expenditure(as % of GDP) in Austria in 1992 and the Expenditure(as % of GDP) in Malaysia in 1993?
Your response must be concise. 0.16. What is the difference between the Expenditure(as % of GDP) in Austria in 1992 and the Expenditure(as % of GDP) in Pakistan in 1993?
Your answer should be very brief. -2.39. What is the difference between the Expenditure(as % of GDP) in Italy in 1992 and the Expenditure(as % of GDP) in Malaysia in 1993?
Offer a terse response. -0.04. What is the difference between the Expenditure(as % of GDP) of Italy in 1992 and the Expenditure(as % of GDP) of Pakistan in 1993?
Provide a succinct answer. -2.58. What is the difference between the Expenditure(as % of GDP) of Malaysia in 1992 and the Expenditure(as % of GDP) of Pakistan in 1993?
Offer a very short reply. -2.55. What is the difference between the Expenditure(as % of GDP) of Austria in 1992 and the Expenditure(as % of GDP) of Italy in 1994?
Your answer should be compact. 0.2. What is the difference between the Expenditure(as % of GDP) in Austria in 1992 and the Expenditure(as % of GDP) in Malaysia in 1994?
Make the answer very short. 0.26. What is the difference between the Expenditure(as % of GDP) of Austria in 1992 and the Expenditure(as % of GDP) of Pakistan in 1994?
Give a very brief answer. -2.95. What is the difference between the Expenditure(as % of GDP) of Italy in 1992 and the Expenditure(as % of GDP) of Malaysia in 1994?
Your answer should be very brief. 0.07. What is the difference between the Expenditure(as % of GDP) in Italy in 1992 and the Expenditure(as % of GDP) in Pakistan in 1994?
Offer a terse response. -3.15. What is the difference between the Expenditure(as % of GDP) of Malaysia in 1992 and the Expenditure(as % of GDP) of Pakistan in 1994?
Offer a terse response. -3.11. What is the difference between the Expenditure(as % of GDP) of Austria in 1993 and the Expenditure(as % of GDP) of Italy in 1994?
Your answer should be compact. 0.18. What is the difference between the Expenditure(as % of GDP) of Austria in 1993 and the Expenditure(as % of GDP) of Malaysia in 1994?
Give a very brief answer. 0.24. What is the difference between the Expenditure(as % of GDP) of Austria in 1993 and the Expenditure(as % of GDP) of Pakistan in 1994?
Your answer should be very brief. -2.97. What is the difference between the Expenditure(as % of GDP) in Italy in 1993 and the Expenditure(as % of GDP) in Malaysia in 1994?
Provide a succinct answer. 0.09. What is the difference between the Expenditure(as % of GDP) of Italy in 1993 and the Expenditure(as % of GDP) of Pakistan in 1994?
Keep it short and to the point. -3.12. What is the difference between the Expenditure(as % of GDP) in Malaysia in 1993 and the Expenditure(as % of GDP) in Pakistan in 1994?
Give a very brief answer. -3.11. What is the average Expenditure(as % of GDP) of Austria per year?
Ensure brevity in your answer.  0.39. What is the average Expenditure(as % of GDP) of Italy per year?
Provide a short and direct response. 0.38. What is the average Expenditure(as % of GDP) of Malaysia per year?
Offer a very short reply. 0.27. What is the average Expenditure(as % of GDP) of Pakistan per year?
Make the answer very short. 4.28. In the year 1987, what is the difference between the Expenditure(as % of GDP) in Austria and Expenditure(as % of GDP) in Italy?
Make the answer very short. -0.23. In the year 1987, what is the difference between the Expenditure(as % of GDP) of Austria and Expenditure(as % of GDP) of Malaysia?
Give a very brief answer. 0.17. In the year 1987, what is the difference between the Expenditure(as % of GDP) in Austria and Expenditure(as % of GDP) in Pakistan?
Ensure brevity in your answer.  -6.21. In the year 1987, what is the difference between the Expenditure(as % of GDP) in Italy and Expenditure(as % of GDP) in Malaysia?
Provide a short and direct response. 0.4. In the year 1987, what is the difference between the Expenditure(as % of GDP) in Italy and Expenditure(as % of GDP) in Pakistan?
Your response must be concise. -5.98. In the year 1987, what is the difference between the Expenditure(as % of GDP) of Malaysia and Expenditure(as % of GDP) of Pakistan?
Make the answer very short. -6.39. In the year 1988, what is the difference between the Expenditure(as % of GDP) in Austria and Expenditure(as % of GDP) in Italy?
Offer a terse response. -0.21. In the year 1988, what is the difference between the Expenditure(as % of GDP) of Austria and Expenditure(as % of GDP) of Malaysia?
Offer a very short reply. 0.06. In the year 1988, what is the difference between the Expenditure(as % of GDP) of Austria and Expenditure(as % of GDP) of Pakistan?
Keep it short and to the point. -4.53. In the year 1988, what is the difference between the Expenditure(as % of GDP) of Italy and Expenditure(as % of GDP) of Malaysia?
Your answer should be very brief. 0.26. In the year 1988, what is the difference between the Expenditure(as % of GDP) in Italy and Expenditure(as % of GDP) in Pakistan?
Your answer should be compact. -4.32. In the year 1988, what is the difference between the Expenditure(as % of GDP) of Malaysia and Expenditure(as % of GDP) of Pakistan?
Ensure brevity in your answer.  -4.58. In the year 1989, what is the difference between the Expenditure(as % of GDP) of Austria and Expenditure(as % of GDP) of Italy?
Make the answer very short. -0.2. In the year 1989, what is the difference between the Expenditure(as % of GDP) in Austria and Expenditure(as % of GDP) in Malaysia?
Make the answer very short. -0. In the year 1989, what is the difference between the Expenditure(as % of GDP) of Austria and Expenditure(as % of GDP) of Pakistan?
Offer a terse response. -4.67. In the year 1989, what is the difference between the Expenditure(as % of GDP) in Italy and Expenditure(as % of GDP) in Malaysia?
Your answer should be very brief. 0.19. In the year 1989, what is the difference between the Expenditure(as % of GDP) of Italy and Expenditure(as % of GDP) of Pakistan?
Your response must be concise. -4.47. In the year 1989, what is the difference between the Expenditure(as % of GDP) of Malaysia and Expenditure(as % of GDP) of Pakistan?
Give a very brief answer. -4.66. In the year 1990, what is the difference between the Expenditure(as % of GDP) in Austria and Expenditure(as % of GDP) in Italy?
Make the answer very short. -0.05. In the year 1990, what is the difference between the Expenditure(as % of GDP) in Austria and Expenditure(as % of GDP) in Malaysia?
Make the answer very short. -0.04. In the year 1990, what is the difference between the Expenditure(as % of GDP) in Austria and Expenditure(as % of GDP) in Pakistan?
Keep it short and to the point. -4.63. In the year 1990, what is the difference between the Expenditure(as % of GDP) in Italy and Expenditure(as % of GDP) in Malaysia?
Offer a terse response. 0.01. In the year 1990, what is the difference between the Expenditure(as % of GDP) of Italy and Expenditure(as % of GDP) of Pakistan?
Offer a terse response. -4.58. In the year 1990, what is the difference between the Expenditure(as % of GDP) of Malaysia and Expenditure(as % of GDP) of Pakistan?
Ensure brevity in your answer.  -4.59. In the year 1991, what is the difference between the Expenditure(as % of GDP) of Austria and Expenditure(as % of GDP) of Italy?
Give a very brief answer. 0.15. In the year 1991, what is the difference between the Expenditure(as % of GDP) in Austria and Expenditure(as % of GDP) in Malaysia?
Provide a short and direct response. 0.18. In the year 1991, what is the difference between the Expenditure(as % of GDP) of Austria and Expenditure(as % of GDP) of Pakistan?
Make the answer very short. -2.96. In the year 1991, what is the difference between the Expenditure(as % of GDP) in Italy and Expenditure(as % of GDP) in Malaysia?
Make the answer very short. 0.03. In the year 1991, what is the difference between the Expenditure(as % of GDP) of Italy and Expenditure(as % of GDP) of Pakistan?
Offer a terse response. -3.11. In the year 1991, what is the difference between the Expenditure(as % of GDP) of Malaysia and Expenditure(as % of GDP) of Pakistan?
Offer a terse response. -3.14. In the year 1992, what is the difference between the Expenditure(as % of GDP) in Austria and Expenditure(as % of GDP) in Italy?
Provide a short and direct response. 0.19. In the year 1992, what is the difference between the Expenditure(as % of GDP) in Austria and Expenditure(as % of GDP) in Malaysia?
Keep it short and to the point. 0.16. In the year 1992, what is the difference between the Expenditure(as % of GDP) of Austria and Expenditure(as % of GDP) of Pakistan?
Provide a short and direct response. -2.82. In the year 1992, what is the difference between the Expenditure(as % of GDP) of Italy and Expenditure(as % of GDP) of Malaysia?
Offer a very short reply. -0.03. In the year 1992, what is the difference between the Expenditure(as % of GDP) of Italy and Expenditure(as % of GDP) of Pakistan?
Offer a very short reply. -3.01. In the year 1992, what is the difference between the Expenditure(as % of GDP) of Malaysia and Expenditure(as % of GDP) of Pakistan?
Your answer should be compact. -2.98. In the year 1993, what is the difference between the Expenditure(as % of GDP) in Austria and Expenditure(as % of GDP) in Italy?
Make the answer very short. 0.15. In the year 1993, what is the difference between the Expenditure(as % of GDP) of Austria and Expenditure(as % of GDP) of Malaysia?
Provide a succinct answer. 0.14. In the year 1993, what is the difference between the Expenditure(as % of GDP) of Austria and Expenditure(as % of GDP) of Pakistan?
Your response must be concise. -2.4. In the year 1993, what is the difference between the Expenditure(as % of GDP) in Italy and Expenditure(as % of GDP) in Malaysia?
Ensure brevity in your answer.  -0.01. In the year 1993, what is the difference between the Expenditure(as % of GDP) in Italy and Expenditure(as % of GDP) in Pakistan?
Your response must be concise. -2.56. In the year 1993, what is the difference between the Expenditure(as % of GDP) of Malaysia and Expenditure(as % of GDP) of Pakistan?
Offer a terse response. -2.55. In the year 1994, what is the difference between the Expenditure(as % of GDP) of Austria and Expenditure(as % of GDP) of Italy?
Provide a succinct answer. 0.2. In the year 1994, what is the difference between the Expenditure(as % of GDP) in Austria and Expenditure(as % of GDP) in Malaysia?
Keep it short and to the point. 0.26. In the year 1994, what is the difference between the Expenditure(as % of GDP) of Austria and Expenditure(as % of GDP) of Pakistan?
Your answer should be very brief. -2.95. In the year 1994, what is the difference between the Expenditure(as % of GDP) in Italy and Expenditure(as % of GDP) in Malaysia?
Make the answer very short. 0.06. In the year 1994, what is the difference between the Expenditure(as % of GDP) of Italy and Expenditure(as % of GDP) of Pakistan?
Give a very brief answer. -3.15. In the year 1994, what is the difference between the Expenditure(as % of GDP) in Malaysia and Expenditure(as % of GDP) in Pakistan?
Your answer should be very brief. -3.21. What is the ratio of the Expenditure(as % of GDP) in Austria in 1987 to that in 1988?
Your answer should be very brief. 0.96. What is the ratio of the Expenditure(as % of GDP) in Italy in 1987 to that in 1988?
Ensure brevity in your answer.  1.02. What is the ratio of the Expenditure(as % of GDP) of Malaysia in 1987 to that in 1988?
Give a very brief answer. 0.54. What is the ratio of the Expenditure(as % of GDP) in Pakistan in 1987 to that in 1988?
Provide a short and direct response. 1.34. What is the ratio of the Expenditure(as % of GDP) in Austria in 1987 to that in 1989?
Offer a very short reply. 0.91. What is the ratio of the Expenditure(as % of GDP) of Italy in 1987 to that in 1989?
Give a very brief answer. 1.01. What is the ratio of the Expenditure(as % of GDP) in Malaysia in 1987 to that in 1989?
Make the answer very short. 0.42. What is the ratio of the Expenditure(as % of GDP) in Pakistan in 1987 to that in 1989?
Give a very brief answer. 1.3. What is the ratio of the Expenditure(as % of GDP) in Austria in 1987 to that in 1990?
Make the answer very short. 0.85. What is the ratio of the Expenditure(as % of GDP) of Italy in 1987 to that in 1990?
Make the answer very short. 1.29. What is the ratio of the Expenditure(as % of GDP) in Malaysia in 1987 to that in 1990?
Ensure brevity in your answer.  0.36. What is the ratio of the Expenditure(as % of GDP) of Pakistan in 1987 to that in 1990?
Keep it short and to the point. 1.3. What is the ratio of the Expenditure(as % of GDP) in Austria in 1987 to that in 1991?
Ensure brevity in your answer.  0.73. What is the ratio of the Expenditure(as % of GDP) in Italy in 1987 to that in 1991?
Offer a very short reply. 1.87. What is the ratio of the Expenditure(as % of GDP) of Malaysia in 1987 to that in 1991?
Your answer should be very brief. 0.57. What is the ratio of the Expenditure(as % of GDP) of Pakistan in 1987 to that in 1991?
Offer a very short reply. 1.92. What is the ratio of the Expenditure(as % of GDP) of Austria in 1987 to that in 1992?
Your answer should be compact. 0.77. What is the ratio of the Expenditure(as % of GDP) in Italy in 1987 to that in 1992?
Ensure brevity in your answer.  2.46. What is the ratio of the Expenditure(as % of GDP) of Malaysia in 1987 to that in 1992?
Your answer should be compact. 0.59. What is the ratio of the Expenditure(as % of GDP) of Pakistan in 1987 to that in 1992?
Your response must be concise. 2.02. What is the ratio of the Expenditure(as % of GDP) in Austria in 1987 to that in 1993?
Make the answer very short. 0.8. What is the ratio of the Expenditure(as % of GDP) in Italy in 1987 to that in 1993?
Give a very brief answer. 2.21. What is the ratio of the Expenditure(as % of GDP) of Malaysia in 1987 to that in 1993?
Provide a short and direct response. 0.58. What is the ratio of the Expenditure(as % of GDP) in Pakistan in 1987 to that in 1993?
Ensure brevity in your answer.  2.33. What is the ratio of the Expenditure(as % of GDP) of Austria in 1987 to that in 1994?
Provide a succinct answer. 0.78. What is the ratio of the Expenditure(as % of GDP) of Italy in 1987 to that in 1994?
Your answer should be very brief. 2.52. What is the ratio of the Expenditure(as % of GDP) of Malaysia in 1987 to that in 1994?
Give a very brief answer. 0.95. What is the ratio of the Expenditure(as % of GDP) in Pakistan in 1987 to that in 1994?
Provide a short and direct response. 1.94. What is the ratio of the Expenditure(as % of GDP) in Austria in 1988 to that in 1989?
Provide a short and direct response. 0.95. What is the ratio of the Expenditure(as % of GDP) of Italy in 1988 to that in 1989?
Provide a short and direct response. 0.99. What is the ratio of the Expenditure(as % of GDP) in Malaysia in 1988 to that in 1989?
Make the answer very short. 0.79. What is the ratio of the Expenditure(as % of GDP) of Pakistan in 1988 to that in 1989?
Give a very brief answer. 0.97. What is the ratio of the Expenditure(as % of GDP) in Austria in 1988 to that in 1990?
Ensure brevity in your answer.  0.88. What is the ratio of the Expenditure(as % of GDP) of Italy in 1988 to that in 1990?
Offer a very short reply. 1.26. What is the ratio of the Expenditure(as % of GDP) in Malaysia in 1988 to that in 1990?
Keep it short and to the point. 0.67. What is the ratio of the Expenditure(as % of GDP) in Pakistan in 1988 to that in 1990?
Give a very brief answer. 0.97. What is the ratio of the Expenditure(as % of GDP) in Austria in 1988 to that in 1991?
Ensure brevity in your answer.  0.76. What is the ratio of the Expenditure(as % of GDP) in Italy in 1988 to that in 1991?
Give a very brief answer. 1.82. What is the ratio of the Expenditure(as % of GDP) of Malaysia in 1988 to that in 1991?
Keep it short and to the point. 1.07. What is the ratio of the Expenditure(as % of GDP) in Pakistan in 1988 to that in 1991?
Give a very brief answer. 1.43. What is the ratio of the Expenditure(as % of GDP) of Austria in 1988 to that in 1992?
Provide a succinct answer. 0.81. What is the ratio of the Expenditure(as % of GDP) in Italy in 1988 to that in 1992?
Offer a terse response. 2.41. What is the ratio of the Expenditure(as % of GDP) in Malaysia in 1988 to that in 1992?
Your answer should be very brief. 1.09. What is the ratio of the Expenditure(as % of GDP) in Pakistan in 1988 to that in 1992?
Your answer should be very brief. 1.5. What is the ratio of the Expenditure(as % of GDP) of Austria in 1988 to that in 1993?
Give a very brief answer. 0.83. What is the ratio of the Expenditure(as % of GDP) in Italy in 1988 to that in 1993?
Your answer should be very brief. 2.16. What is the ratio of the Expenditure(as % of GDP) of Malaysia in 1988 to that in 1993?
Ensure brevity in your answer.  1.08. What is the ratio of the Expenditure(as % of GDP) of Pakistan in 1988 to that in 1993?
Offer a terse response. 1.73. What is the ratio of the Expenditure(as % of GDP) in Austria in 1988 to that in 1994?
Give a very brief answer. 0.81. What is the ratio of the Expenditure(as % of GDP) of Italy in 1988 to that in 1994?
Offer a terse response. 2.46. What is the ratio of the Expenditure(as % of GDP) of Malaysia in 1988 to that in 1994?
Your answer should be compact. 1.76. What is the ratio of the Expenditure(as % of GDP) of Pakistan in 1988 to that in 1994?
Ensure brevity in your answer.  1.44. What is the ratio of the Expenditure(as % of GDP) in Austria in 1989 to that in 1990?
Make the answer very short. 0.93. What is the ratio of the Expenditure(as % of GDP) of Italy in 1989 to that in 1990?
Your answer should be very brief. 1.27. What is the ratio of the Expenditure(as % of GDP) in Malaysia in 1989 to that in 1990?
Offer a terse response. 0.85. What is the ratio of the Expenditure(as % of GDP) of Pakistan in 1989 to that in 1990?
Offer a very short reply. 1. What is the ratio of the Expenditure(as % of GDP) of Austria in 1989 to that in 1991?
Your answer should be very brief. 0.79. What is the ratio of the Expenditure(as % of GDP) in Italy in 1989 to that in 1991?
Offer a terse response. 1.84. What is the ratio of the Expenditure(as % of GDP) of Malaysia in 1989 to that in 1991?
Offer a very short reply. 1.35. What is the ratio of the Expenditure(as % of GDP) of Pakistan in 1989 to that in 1991?
Provide a short and direct response. 1.47. What is the ratio of the Expenditure(as % of GDP) of Austria in 1989 to that in 1992?
Give a very brief answer. 0.84. What is the ratio of the Expenditure(as % of GDP) in Italy in 1989 to that in 1992?
Keep it short and to the point. 2.43. What is the ratio of the Expenditure(as % of GDP) in Malaysia in 1989 to that in 1992?
Give a very brief answer. 1.38. What is the ratio of the Expenditure(as % of GDP) in Pakistan in 1989 to that in 1992?
Your answer should be compact. 1.55. What is the ratio of the Expenditure(as % of GDP) of Austria in 1989 to that in 1993?
Ensure brevity in your answer.  0.87. What is the ratio of the Expenditure(as % of GDP) in Italy in 1989 to that in 1993?
Provide a succinct answer. 2.18. What is the ratio of the Expenditure(as % of GDP) of Malaysia in 1989 to that in 1993?
Offer a very short reply. 1.36. What is the ratio of the Expenditure(as % of GDP) of Pakistan in 1989 to that in 1993?
Offer a terse response. 1.79. What is the ratio of the Expenditure(as % of GDP) of Austria in 1989 to that in 1994?
Offer a terse response. 0.85. What is the ratio of the Expenditure(as % of GDP) in Italy in 1989 to that in 1994?
Offer a terse response. 2.49. What is the ratio of the Expenditure(as % of GDP) of Malaysia in 1989 to that in 1994?
Offer a very short reply. 2.23. What is the ratio of the Expenditure(as % of GDP) in Pakistan in 1989 to that in 1994?
Your answer should be compact. 1.49. What is the ratio of the Expenditure(as % of GDP) of Austria in 1990 to that in 1991?
Your answer should be very brief. 0.86. What is the ratio of the Expenditure(as % of GDP) in Italy in 1990 to that in 1991?
Your answer should be very brief. 1.45. What is the ratio of the Expenditure(as % of GDP) in Malaysia in 1990 to that in 1991?
Your answer should be compact. 1.59. What is the ratio of the Expenditure(as % of GDP) in Pakistan in 1990 to that in 1991?
Your response must be concise. 1.47. What is the ratio of the Expenditure(as % of GDP) in Austria in 1990 to that in 1992?
Your answer should be very brief. 0.91. What is the ratio of the Expenditure(as % of GDP) in Italy in 1990 to that in 1992?
Give a very brief answer. 1.91. What is the ratio of the Expenditure(as % of GDP) in Malaysia in 1990 to that in 1992?
Keep it short and to the point. 1.63. What is the ratio of the Expenditure(as % of GDP) of Pakistan in 1990 to that in 1992?
Provide a short and direct response. 1.55. What is the ratio of the Expenditure(as % of GDP) in Austria in 1990 to that in 1993?
Your answer should be compact. 0.94. What is the ratio of the Expenditure(as % of GDP) of Italy in 1990 to that in 1993?
Offer a very short reply. 1.71. What is the ratio of the Expenditure(as % of GDP) of Malaysia in 1990 to that in 1993?
Offer a very short reply. 1.6. What is the ratio of the Expenditure(as % of GDP) in Pakistan in 1990 to that in 1993?
Ensure brevity in your answer.  1.78. What is the ratio of the Expenditure(as % of GDP) in Austria in 1990 to that in 1994?
Give a very brief answer. 0.92. What is the ratio of the Expenditure(as % of GDP) of Italy in 1990 to that in 1994?
Your answer should be very brief. 1.95. What is the ratio of the Expenditure(as % of GDP) of Malaysia in 1990 to that in 1994?
Offer a terse response. 2.63. What is the ratio of the Expenditure(as % of GDP) in Pakistan in 1990 to that in 1994?
Your response must be concise. 1.49. What is the ratio of the Expenditure(as % of GDP) of Austria in 1991 to that in 1992?
Make the answer very short. 1.06. What is the ratio of the Expenditure(as % of GDP) of Italy in 1991 to that in 1992?
Offer a terse response. 1.32. What is the ratio of the Expenditure(as % of GDP) of Malaysia in 1991 to that in 1992?
Your answer should be very brief. 1.02. What is the ratio of the Expenditure(as % of GDP) in Pakistan in 1991 to that in 1992?
Make the answer very short. 1.05. What is the ratio of the Expenditure(as % of GDP) of Austria in 1991 to that in 1993?
Give a very brief answer. 1.1. What is the ratio of the Expenditure(as % of GDP) in Italy in 1991 to that in 1993?
Keep it short and to the point. 1.18. What is the ratio of the Expenditure(as % of GDP) of Malaysia in 1991 to that in 1993?
Your response must be concise. 1.01. What is the ratio of the Expenditure(as % of GDP) of Pakistan in 1991 to that in 1993?
Make the answer very short. 1.21. What is the ratio of the Expenditure(as % of GDP) in Austria in 1991 to that in 1994?
Give a very brief answer. 1.07. What is the ratio of the Expenditure(as % of GDP) of Italy in 1991 to that in 1994?
Your answer should be compact. 1.35. What is the ratio of the Expenditure(as % of GDP) of Malaysia in 1991 to that in 1994?
Offer a very short reply. 1.65. What is the ratio of the Expenditure(as % of GDP) of Pakistan in 1991 to that in 1994?
Make the answer very short. 1.01. What is the ratio of the Expenditure(as % of GDP) in Austria in 1992 to that in 1993?
Provide a succinct answer. 1.03. What is the ratio of the Expenditure(as % of GDP) in Italy in 1992 to that in 1993?
Provide a succinct answer. 0.9. What is the ratio of the Expenditure(as % of GDP) of Malaysia in 1992 to that in 1993?
Provide a short and direct response. 0.99. What is the ratio of the Expenditure(as % of GDP) of Pakistan in 1992 to that in 1993?
Give a very brief answer. 1.15. What is the ratio of the Expenditure(as % of GDP) in Austria in 1992 to that in 1994?
Give a very brief answer. 1.01. What is the ratio of the Expenditure(as % of GDP) of Italy in 1992 to that in 1994?
Offer a terse response. 1.02. What is the ratio of the Expenditure(as % of GDP) in Malaysia in 1992 to that in 1994?
Your response must be concise. 1.62. What is the ratio of the Expenditure(as % of GDP) of Pakistan in 1992 to that in 1994?
Make the answer very short. 0.96. What is the ratio of the Expenditure(as % of GDP) of Italy in 1993 to that in 1994?
Offer a terse response. 1.14. What is the ratio of the Expenditure(as % of GDP) of Malaysia in 1993 to that in 1994?
Ensure brevity in your answer.  1.64. What is the ratio of the Expenditure(as % of GDP) of Pakistan in 1993 to that in 1994?
Ensure brevity in your answer.  0.83. What is the difference between the highest and the second highest Expenditure(as % of GDP) of Austria?
Your answer should be very brief. 0.03. What is the difference between the highest and the second highest Expenditure(as % of GDP) in Italy?
Ensure brevity in your answer.  0.01. What is the difference between the highest and the second highest Expenditure(as % of GDP) in Malaysia?
Provide a succinct answer. 0.06. What is the difference between the highest and the second highest Expenditure(as % of GDP) in Pakistan?
Give a very brief answer. 1.52. What is the difference between the highest and the lowest Expenditure(as % of GDP) of Austria?
Make the answer very short. 0.12. What is the difference between the highest and the lowest Expenditure(as % of GDP) in Italy?
Offer a terse response. 0.33. What is the difference between the highest and the lowest Expenditure(as % of GDP) in Malaysia?
Your response must be concise. 0.27. What is the difference between the highest and the lowest Expenditure(as % of GDP) in Pakistan?
Offer a terse response. 3.73. 